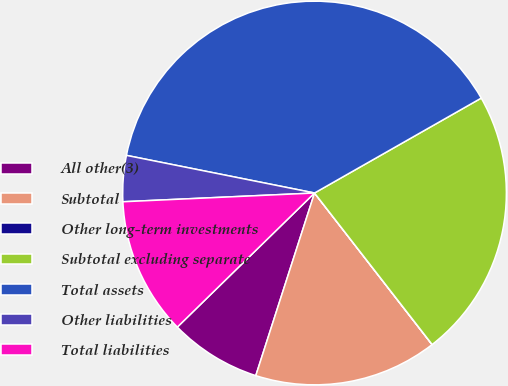<chart> <loc_0><loc_0><loc_500><loc_500><pie_chart><fcel>All other(3)<fcel>Subtotal<fcel>Other long-term investments<fcel>Subtotal excluding separate<fcel>Total assets<fcel>Other liabilities<fcel>Total liabilities<nl><fcel>7.73%<fcel>15.45%<fcel>0.01%<fcel>22.73%<fcel>38.62%<fcel>3.87%<fcel>11.59%<nl></chart> 